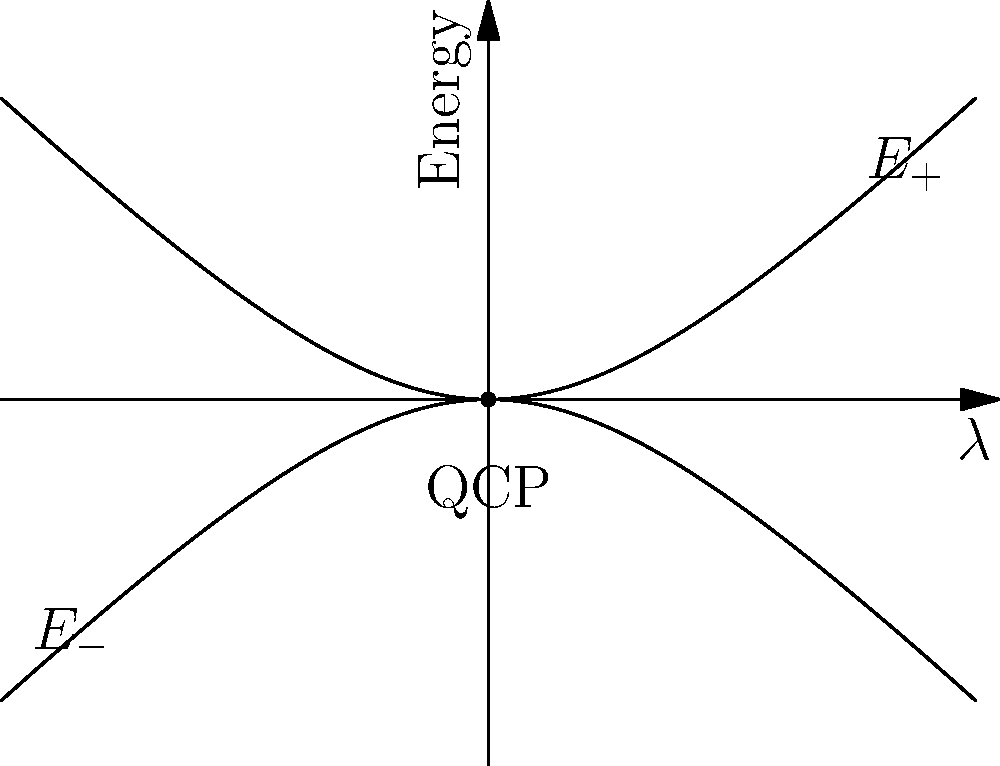Consider a two-level system undergoing an adiabatic evolution across a quantum critical point (QCP) as shown in the figure. The system starts in the ground state at $\lambda \ll -1$ and evolves to $\lambda \gg 1$. Calculate the Berry phase accumulated during this process, given that the energy gap at the QCP scales as $\Delta E \sim |\lambda|^{z\nu}$ with $z\nu = 1/2$. To calculate the Berry phase accumulated during this adiabatic evolution, we can follow these steps:

1) The Berry phase for a cyclic adiabatic evolution is given by:

   $$\gamma = i \oint \langle \psi(\lambda) | \frac{d}{d\lambda} | \psi(\lambda) \rangle d\lambda$$

2) For a two-level system, the Berry phase can be related to the solid angle $\Omega$ enclosed by the path on the Bloch sphere:

   $$\gamma = -\frac{\Omega}{2}$$

3) In the case of evolution across a QCP, the path effectively encloses half of the Bloch sphere, so $\Omega = 2\pi$. Thus:

   $$\gamma = -\pi$$

4) However, this is only true for an idealized, infinitely slow evolution. In reality, there will be corrections due to the finite evolution rate.

5) The correction to the Berry phase scales with the energy gap at the QCP. The Kibble-Zurek mechanism gives us the scaling of the correction:

   $$\delta\gamma \sim (\Delta E)^{-1} \sim |\lambda|^{-z\nu}$$

6) Given that $z\nu = 1/2$, we have:

   $$\delta\gamma \sim |\lambda|^{-1/2}$$

7) Therefore, the total Berry phase accumulated will be:

   $$\gamma_{total} = -\pi + O(|\lambda|^{-1/2})$$

This result shows that in the limit of infinitely slow evolution ($|\lambda| \to \infty$), we recover the ideal Berry phase of $-\pi$.
Answer: $-\pi + O(|\lambda|^{-1/2})$ 